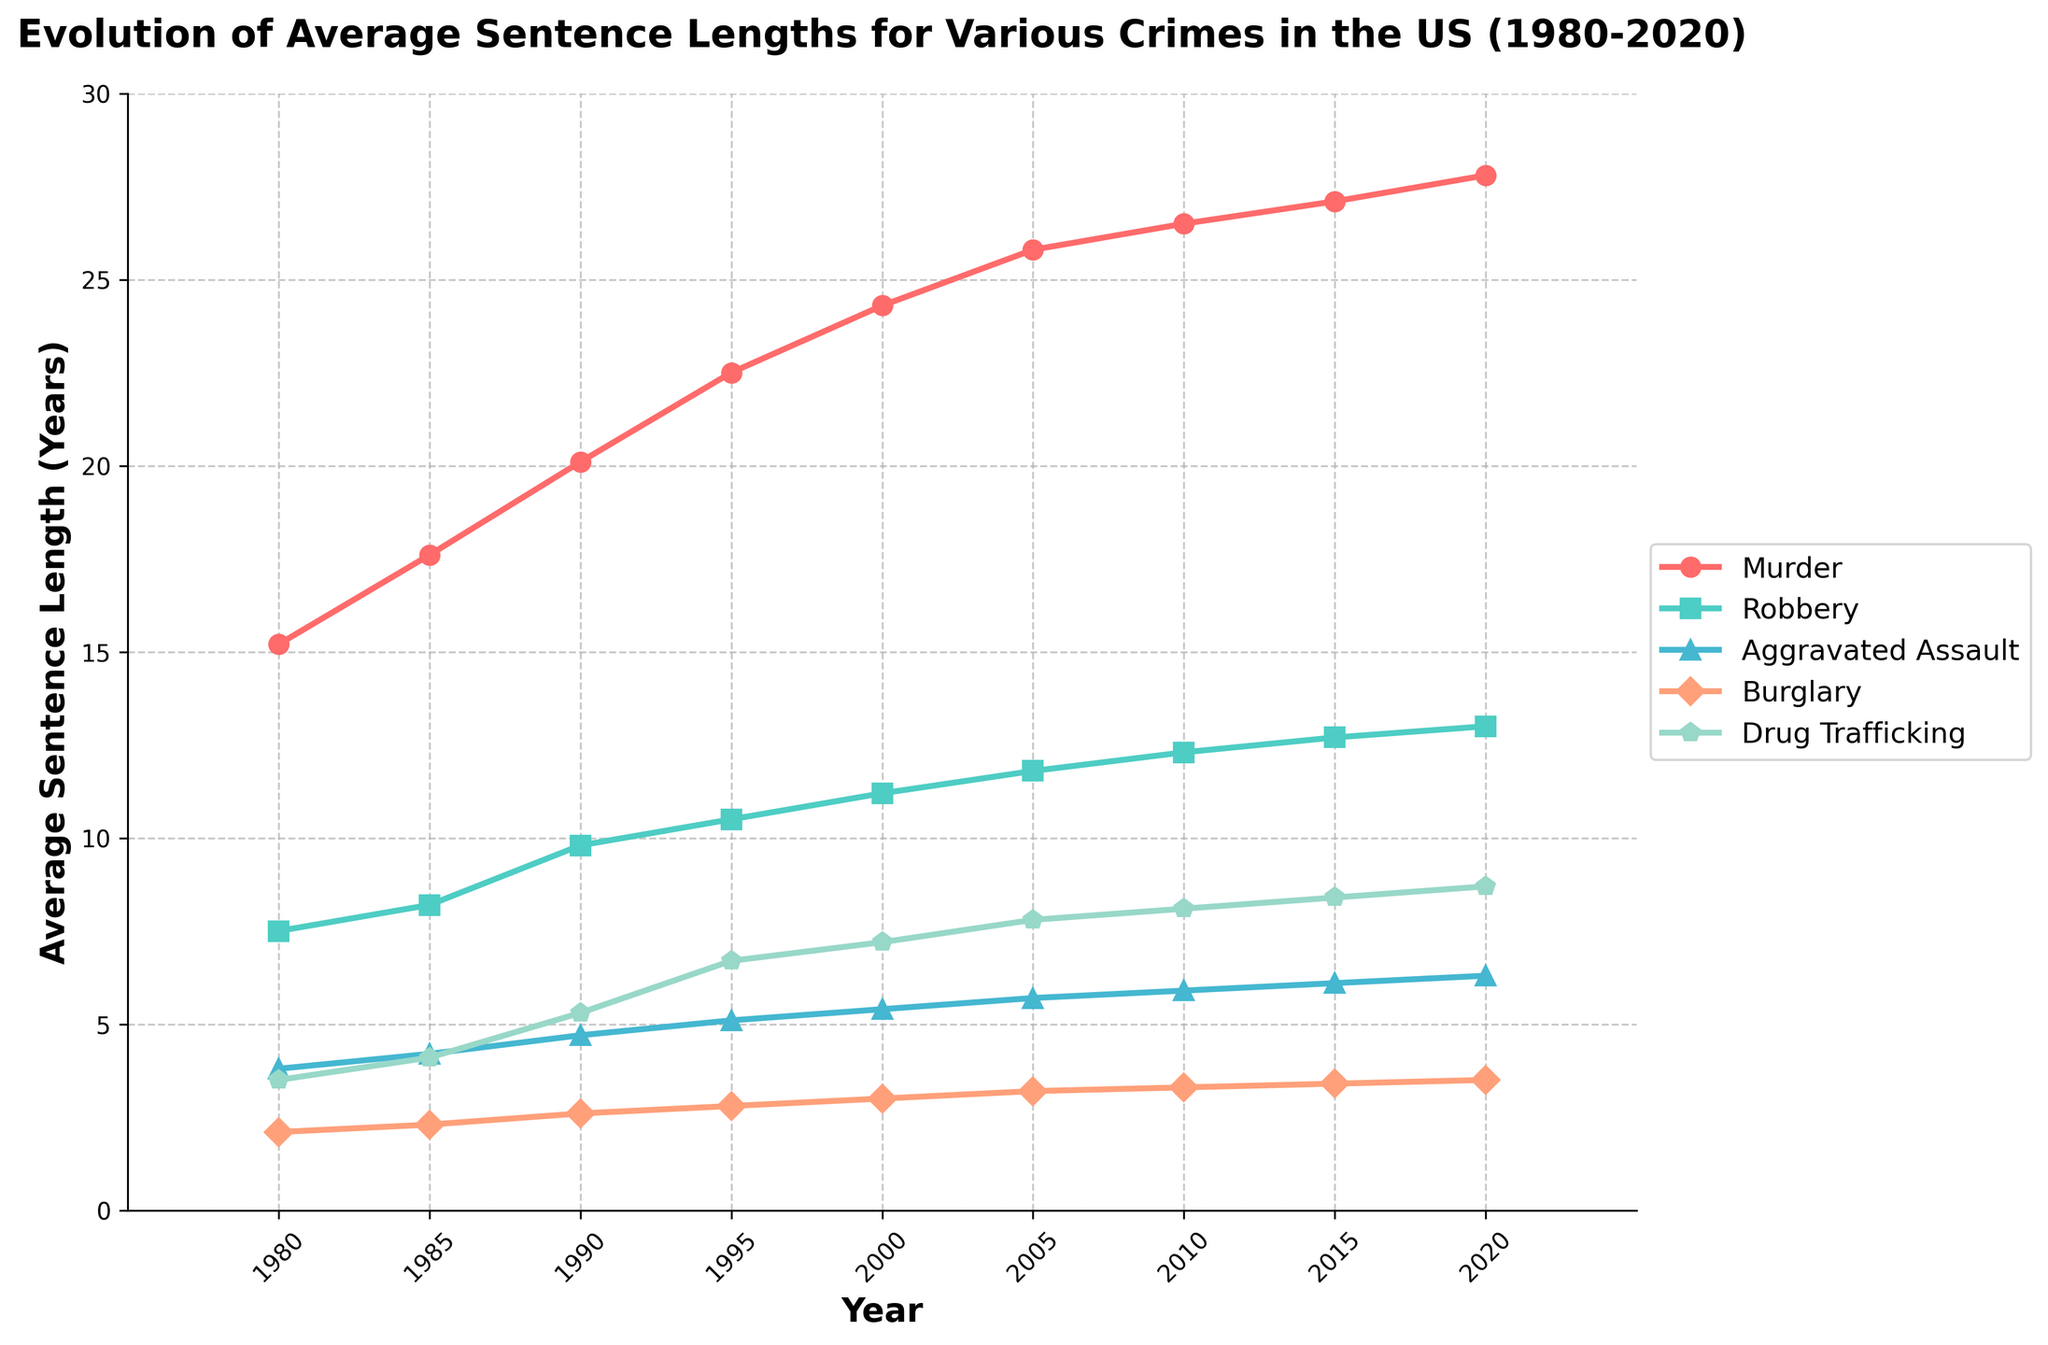Which crime had the longest average sentence length in 1980? By looking at the figure, identify the crime category with the highest point on the Y-axis for the year 1980.
Answer: Murder Between which two years did Drug Trafficking see the greatest increase in average sentence length? Compare the incremental changes in the height of the data points for Drug Trafficking over the years and find the largest difference. The biggest increase is between 1990 and 1995.
Answer: 1990 and 1995 What is the average sentence length of Murder in 2015 and 2020? Locate the points for Murder in 2015 and 2020 on the Y-axis, which are 27.1 and 27.8 respectively. The average is calculated as (27.1 + 27.8) / 2 = 27.45 years.
Answer: 27.45 years Which crime had the smallest increase in sentence length from 1980 to 2020? Determine the difference in the heights of the initial and final points for each crime type. The smallest difference is found by comparing changes for all crimes, which is Burglary (3.5 - 2.1 = 1.4 years).
Answer: Burglary In what year did Aggravated Assault's average sentence length first exceed 5 years? Inspect the points on the plot for Aggravated Assault and identify when they first cross the 5-year mark on the Y-axis, which is in 1995.
Answer: 1995 Compare the sentence lengths for Robbery and Burglary in 2000. Which one is higher, and by how much? Locate the points for both crimes in the year 2000 on the Y-axis. Robbery is 11.2 years and Burglary is 3.0 years. The difference is computed as 11.2 - 3.0 = 8.2 years.
Answer: Robbery by 8.2 years What was the trend for average sentence lengths of Burglary from 1980 to 2020? Examine the line representing Burglary over time. Note if it’s rising, falling, or remaining flat. The line for Burglary shows a slight upward trend over the years.
Answer: Slightly increasing Which crime consistently had the highest average sentence length throughout the entire period from 1980 to 2020? Look at the lines for each crime over the period and identify which crime's line remains above the others. The line for Murder is consistently the highest.
Answer: Murder By what percentage did the average sentence length for Aggravated Assault change from 1985 to 2020? Calculate the change in sentence length for Aggravated Assault (6.3 - 4.2 = 2.1 years) and find the percentage increase relative to 1985: (2.1 / 4.2) * 100 ≈ 50%.
Answer: 50% 